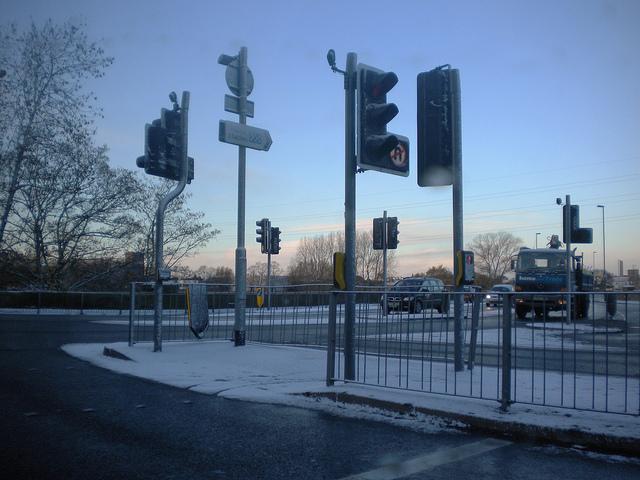How many sets of traffic lights are visible?
Keep it brief. 4. What color is the traffic light?
Write a very short answer. Red. How many vehicles are in view?
Be succinct. 3. What material is the fencing?
Write a very short answer. Metal. Is it cold here?
Short answer required. Yes. In what shape has the snow formed?
Answer briefly. Flat. 